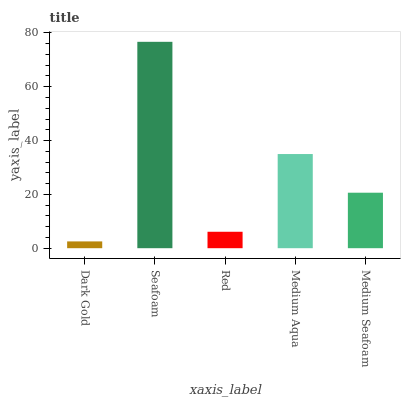Is Dark Gold the minimum?
Answer yes or no. Yes. Is Seafoam the maximum?
Answer yes or no. Yes. Is Red the minimum?
Answer yes or no. No. Is Red the maximum?
Answer yes or no. No. Is Seafoam greater than Red?
Answer yes or no. Yes. Is Red less than Seafoam?
Answer yes or no. Yes. Is Red greater than Seafoam?
Answer yes or no. No. Is Seafoam less than Red?
Answer yes or no. No. Is Medium Seafoam the high median?
Answer yes or no. Yes. Is Medium Seafoam the low median?
Answer yes or no. Yes. Is Medium Aqua the high median?
Answer yes or no. No. Is Seafoam the low median?
Answer yes or no. No. 